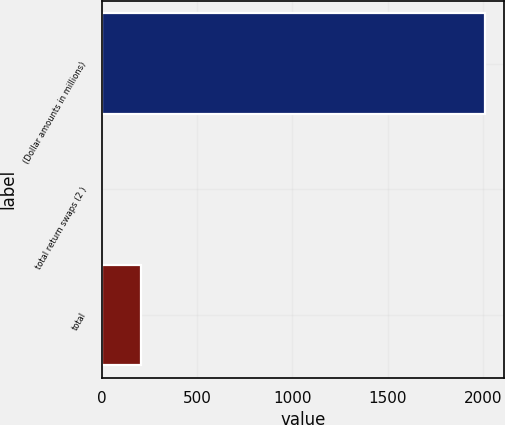<chart> <loc_0><loc_0><loc_500><loc_500><bar_chart><fcel>(Dollar amounts in millions)<fcel>total return swaps (2 )<fcel>total<nl><fcel>2011<fcel>4<fcel>204.7<nl></chart> 